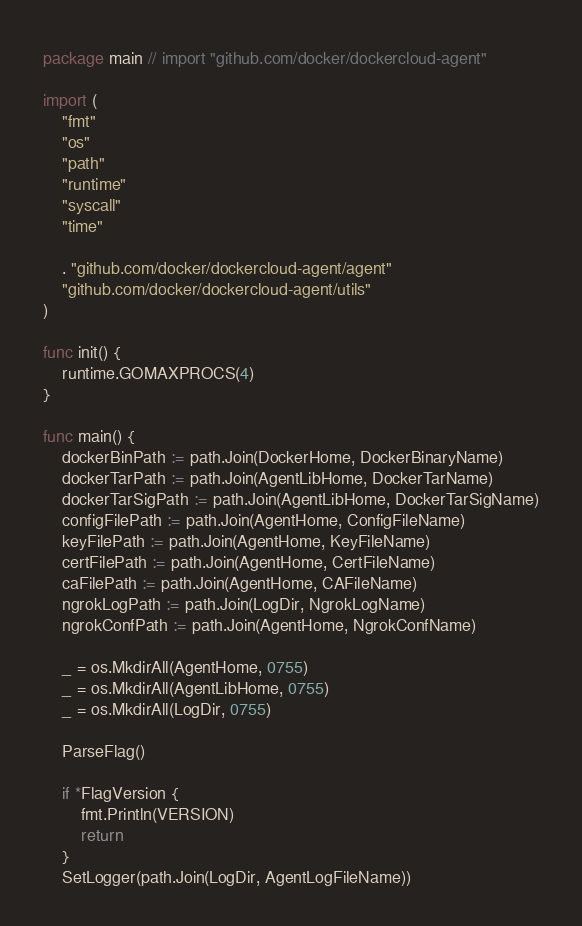Convert code to text. <code><loc_0><loc_0><loc_500><loc_500><_Go_>package main // import "github.com/docker/dockercloud-agent"

import (
	"fmt"
	"os"
	"path"
	"runtime"
	"syscall"
	"time"

	. "github.com/docker/dockercloud-agent/agent"
	"github.com/docker/dockercloud-agent/utils"
)

func init() {
	runtime.GOMAXPROCS(4)
}

func main() {
	dockerBinPath := path.Join(DockerHome, DockerBinaryName)
	dockerTarPath := path.Join(AgentLibHome, DockerTarName)
	dockerTarSigPath := path.Join(AgentLibHome, DockerTarSigName)
	configFilePath := path.Join(AgentHome, ConfigFileName)
	keyFilePath := path.Join(AgentHome, KeyFileName)
	certFilePath := path.Join(AgentHome, CertFileName)
	caFilePath := path.Join(AgentHome, CAFileName)
	ngrokLogPath := path.Join(LogDir, NgrokLogName)
	ngrokConfPath := path.Join(AgentHome, NgrokConfName)

	_ = os.MkdirAll(AgentHome, 0755)
	_ = os.MkdirAll(AgentLibHome, 0755)
	_ = os.MkdirAll(LogDir, 0755)

	ParseFlag()

	if *FlagVersion {
		fmt.Println(VERSION)
		return
	}
	SetLogger(path.Join(LogDir, AgentLogFileName))</code> 